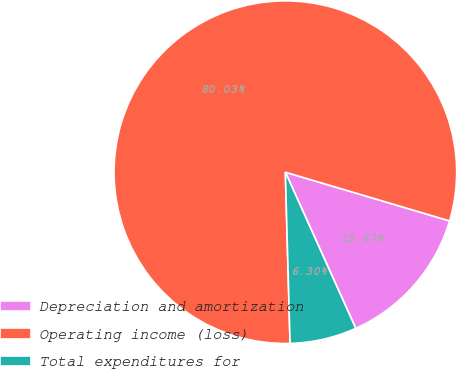Convert chart to OTSL. <chart><loc_0><loc_0><loc_500><loc_500><pie_chart><fcel>Depreciation and amortization<fcel>Operating income (loss)<fcel>Total expenditures for<nl><fcel>13.67%<fcel>80.03%<fcel>6.3%<nl></chart> 